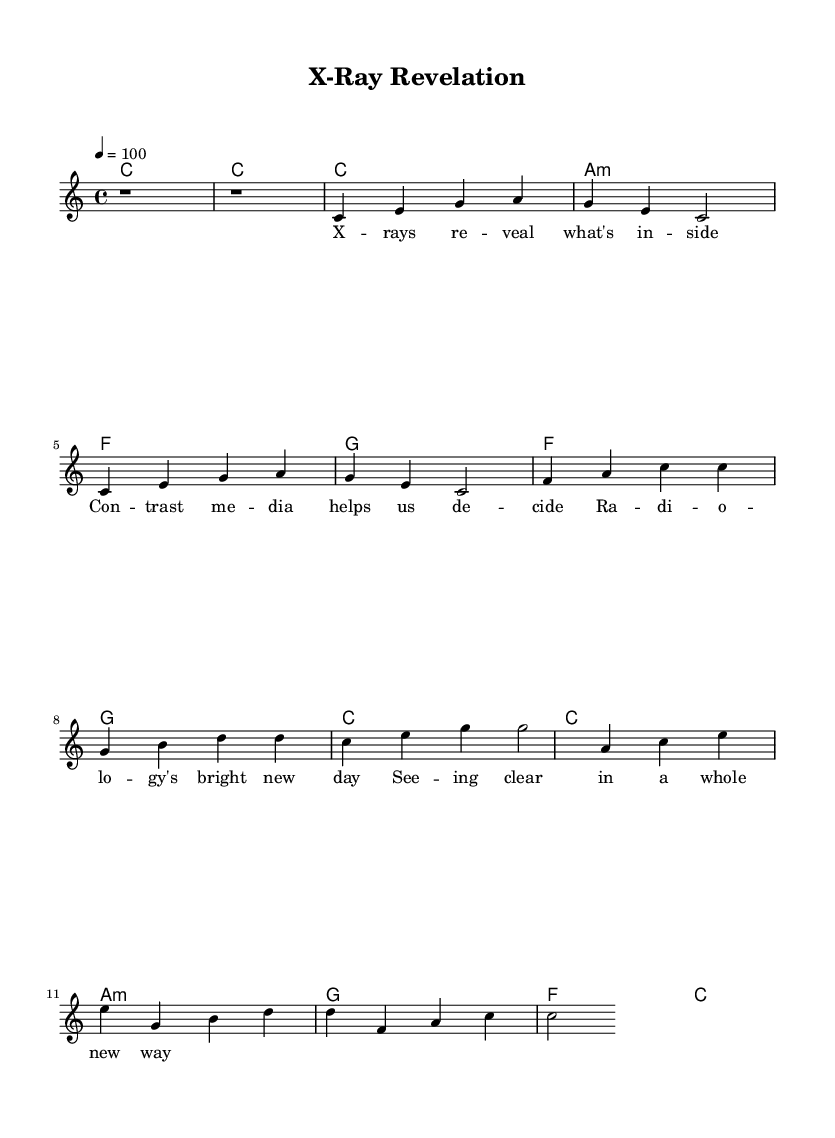What is the key signature of this music? The key signature is indicated by the part of the sheet music that shows no sharps or flats, which corresponds to C major.
Answer: C major What is the time signature of this piece? The time signature is displayed as a fraction at the beginning of the score, indicating that there are four beats in a measure, thus the time signature is 4/4.
Answer: 4/4 What is the tempo marking for the music? The tempo marking of the music is shown with a number, which in this case is '4 = 100', meaning the quarter note is played at 100 beats per minute.
Answer: 100 How many measures are in the verse? To find this, count the number of measures present in the verse section indicated in the melody line. There are four measures in the verse.
Answer: 4 What type of underlying chord is used in the chorus? By examining the chord names in the chorus section, we see that the chords listed are F, G, C, and C, indicating the structure used. The underlying chord for the chorus is dominant.
Answer: Dominant Which section contains the lyrics “X-rays reveal what's inside”? This phrase appears in the verse section of the lyrics, as shown in the lyrics associated with the melody line.
Answer: Verse How many chords are in the bridge? Count the number of distinct chords listed in the bridge section. The chords are A minor, G, F, and C, indicating there are four chords in total.
Answer: 4 